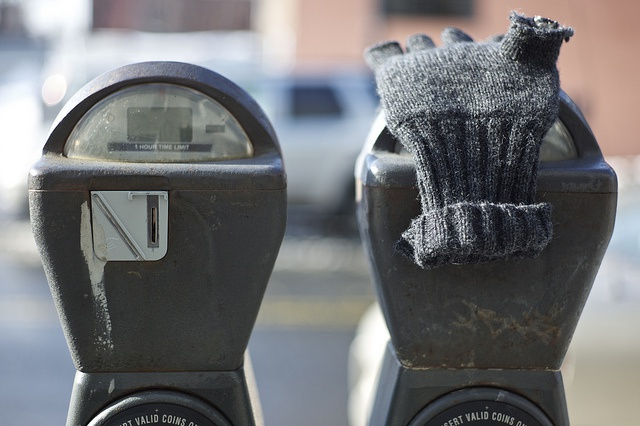Describe the objects in this image and their specific colors. I can see parking meter in darkgray, black, gray, and lightgray tones, parking meter in darkgray, black, gray, and lightgray tones, and car in darkgray, gray, and lightgray tones in this image. 